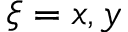<formula> <loc_0><loc_0><loc_500><loc_500>\xi = x , y</formula> 